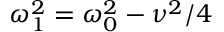<formula> <loc_0><loc_0><loc_500><loc_500>\omega _ { 1 } ^ { 2 } = \omega _ { 0 } ^ { 2 } - \nu ^ { 2 } / 4</formula> 